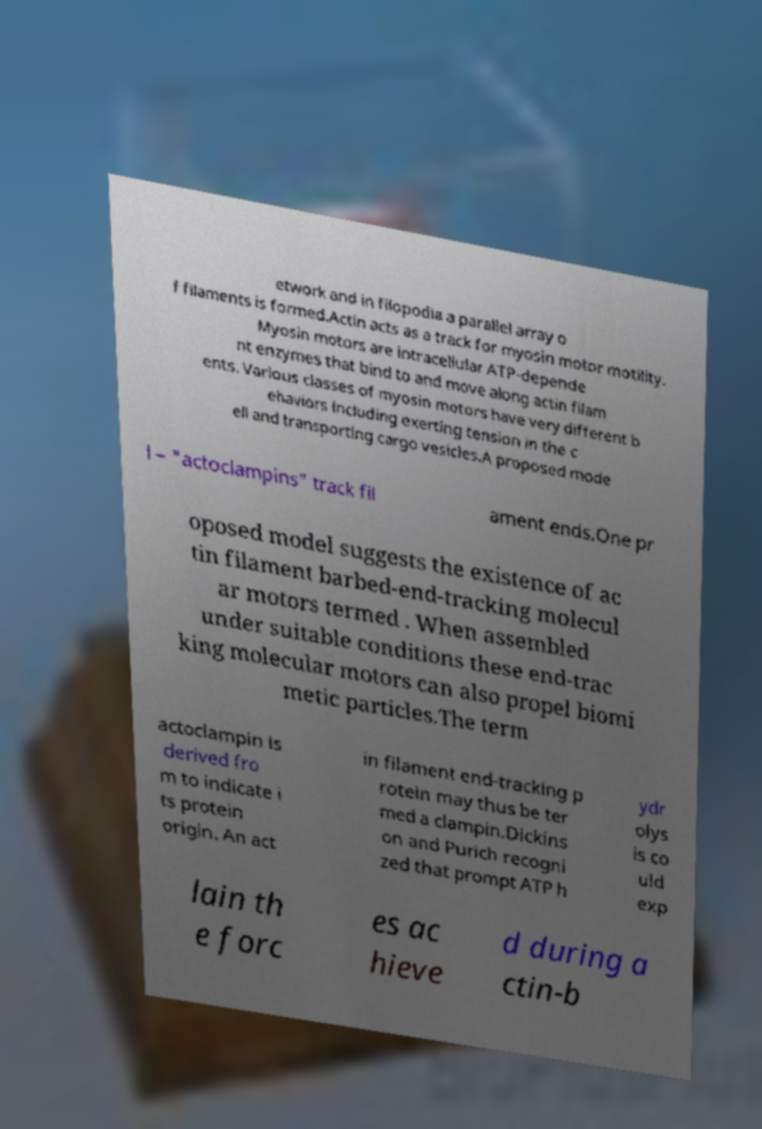Please identify and transcribe the text found in this image. etwork and in filopodia a parallel array o f filaments is formed.Actin acts as a track for myosin motor motility. Myosin motors are intracellular ATP-depende nt enzymes that bind to and move along actin filam ents. Various classes of myosin motors have very different b ehaviors including exerting tension in the c ell and transporting cargo vesicles.A proposed mode l – "actoclampins" track fil ament ends.One pr oposed model suggests the existence of ac tin filament barbed-end-tracking molecul ar motors termed . When assembled under suitable conditions these end-trac king molecular motors can also propel biomi metic particles.The term actoclampin is derived fro m to indicate i ts protein origin. An act in filament end-tracking p rotein may thus be ter med a clampin.Dickins on and Purich recogni zed that prompt ATP h ydr olys is co uld exp lain th e forc es ac hieve d during a ctin-b 